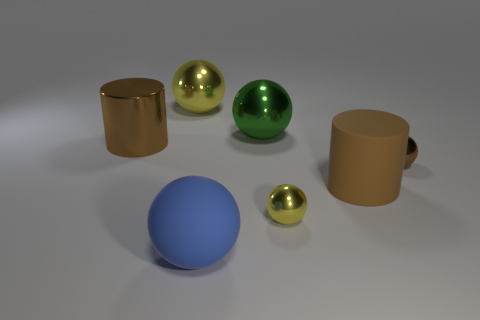Subtract 2 balls. How many balls are left? 3 Subtract all rubber spheres. How many spheres are left? 4 Subtract all purple spheres. Subtract all gray cylinders. How many spheres are left? 5 Add 3 brown rubber things. How many objects exist? 10 Subtract all cylinders. How many objects are left? 5 Subtract 2 yellow balls. How many objects are left? 5 Subtract all yellow balls. Subtract all blue matte balls. How many objects are left? 4 Add 7 large rubber things. How many large rubber things are left? 9 Add 5 big blue objects. How many big blue objects exist? 6 